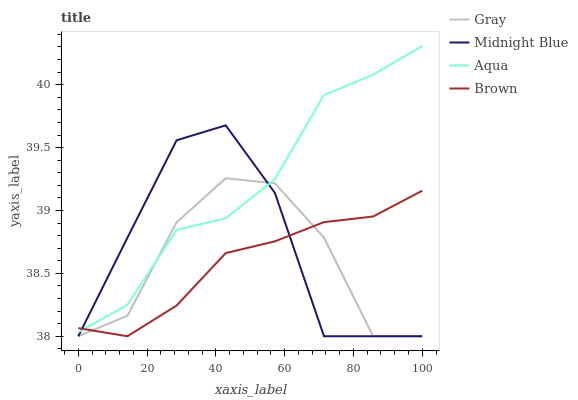Does Midnight Blue have the minimum area under the curve?
Answer yes or no. No. Does Midnight Blue have the maximum area under the curve?
Answer yes or no. No. Is Aqua the smoothest?
Answer yes or no. No. Is Aqua the roughest?
Answer yes or no. No. Does Aqua have the lowest value?
Answer yes or no. No. Does Midnight Blue have the highest value?
Answer yes or no. No. 